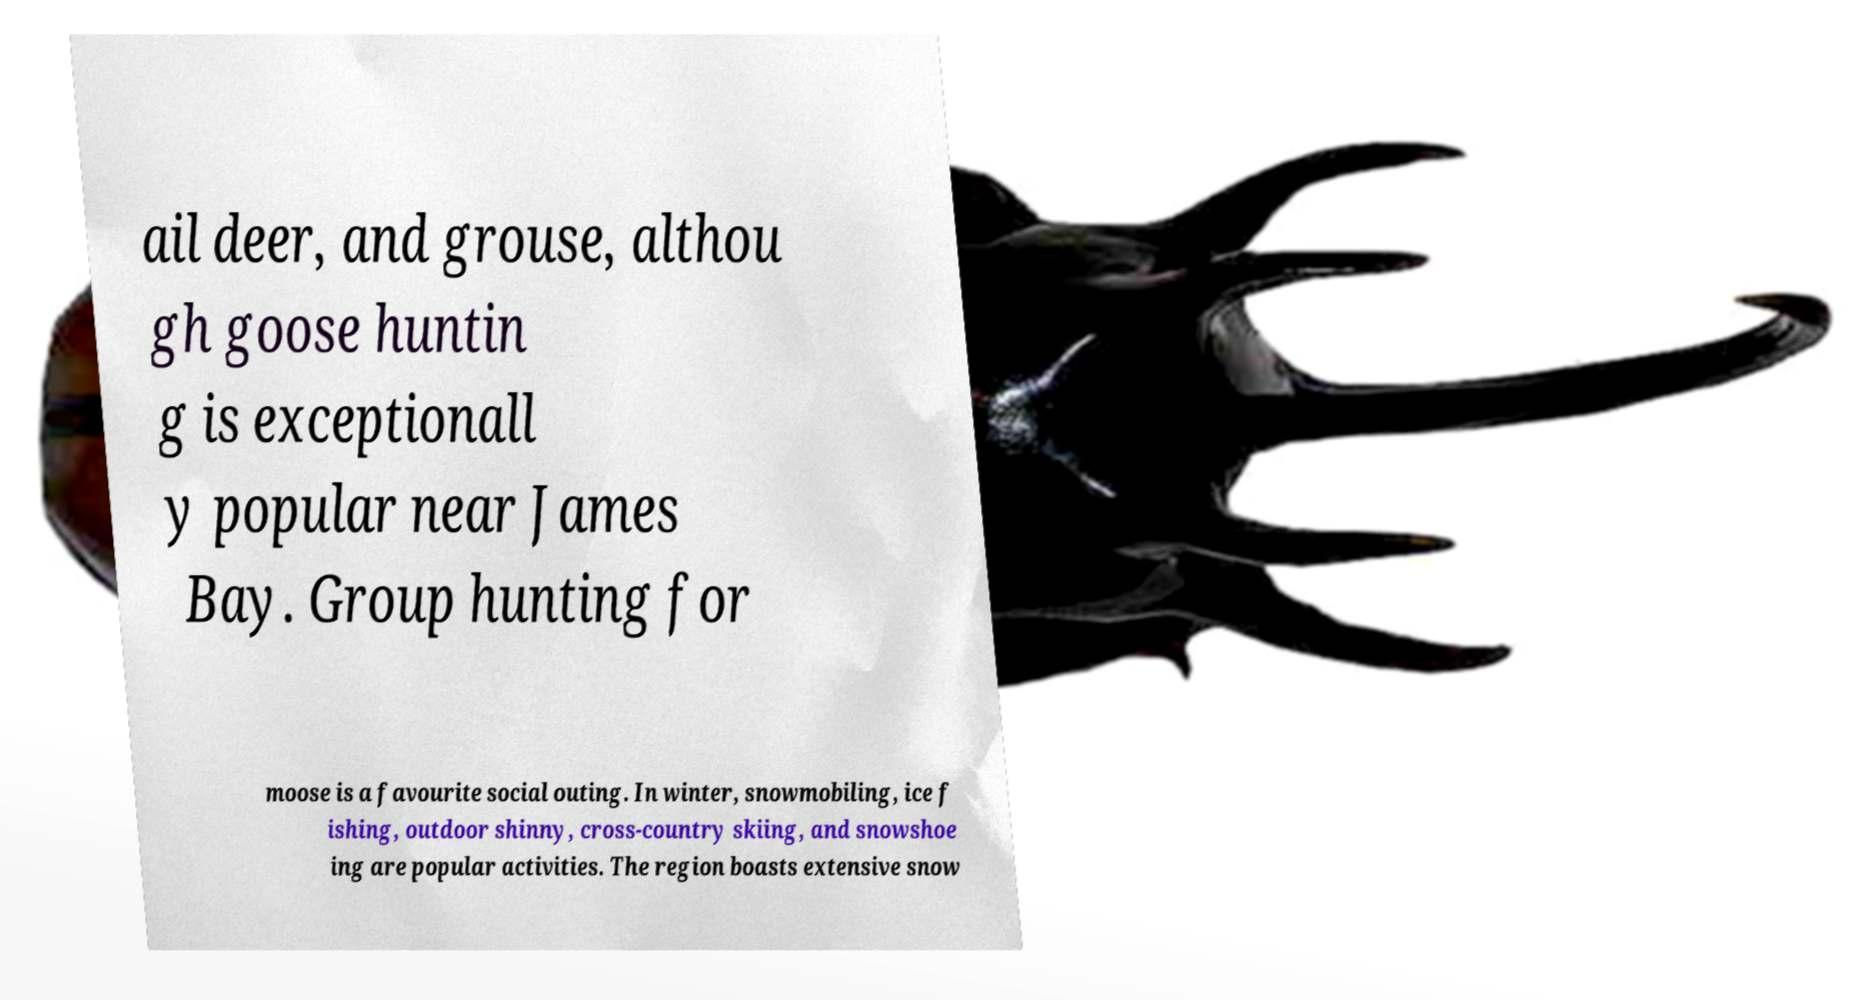Could you assist in decoding the text presented in this image and type it out clearly? ail deer, and grouse, althou gh goose huntin g is exceptionall y popular near James Bay. Group hunting for moose is a favourite social outing. In winter, snowmobiling, ice f ishing, outdoor shinny, cross-country skiing, and snowshoe ing are popular activities. The region boasts extensive snow 